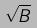Convert formula to latex. <formula><loc_0><loc_0><loc_500><loc_500>\sqrt { B }</formula> 